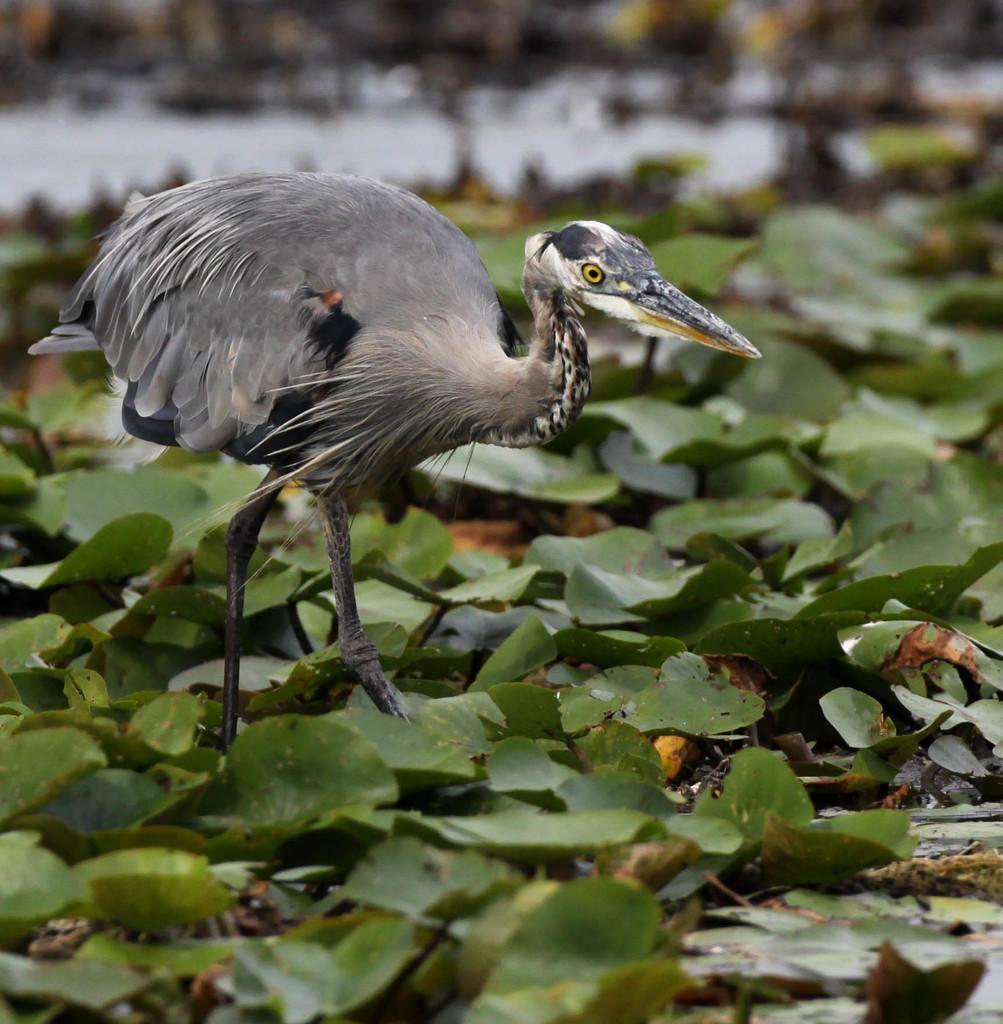Describe this image in one or two sentences. In the picture I can see a bird is standing on the ground. In the background I can see leaves. The background of the image is blurred. 